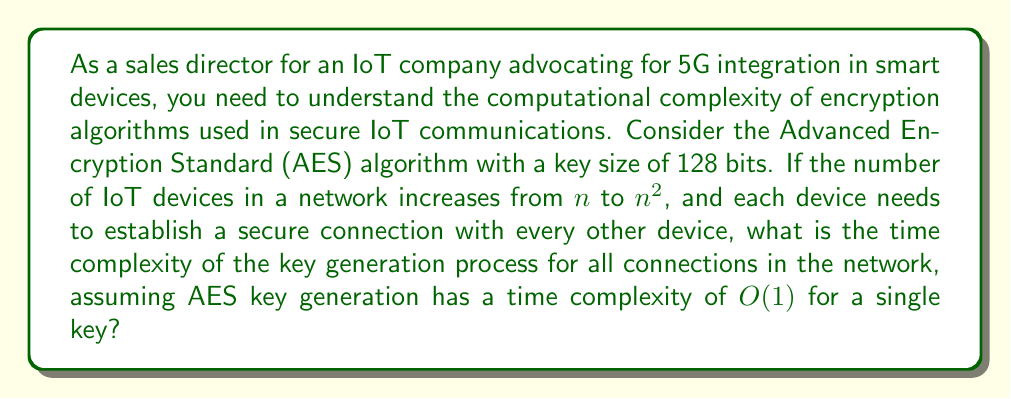Solve this math problem. To solve this problem, let's break it down into steps:

1) First, we need to determine the number of connections in the network:
   - With $n$ devices, each device needs to connect to $(n-1)$ other devices.
   - The total number of connections is $\frac{n(n-1)}{2}$, as each connection is counted twice in the above calculation.

2) When the number of devices increases to $n^2$:
   - The number of connections becomes $\frac{n^2(n^2-1)}{2}$

3) For each connection, we need to generate a key. The AES key generation has a time complexity of $O(1)$ for a single key.

4) Therefore, the total time complexity is proportional to the number of connections:
   $$O(\frac{n^2(n^2-1)}{2})$$

5) Simplifying this expression:
   $$O(\frac{n^4-n^2}{2}) = O(n^4-n^2) = O(n^4)$$

6) In Big O notation, we only keep the highest order term, so the final time complexity is $O(n^4)$.

This quartic time complexity indicates that the key generation process for all connections in the network becomes significantly more computationally intensive as the number of devices increases, which is an important consideration when scaling IoT networks with 5G integration.
Answer: $O(n^4)$ 